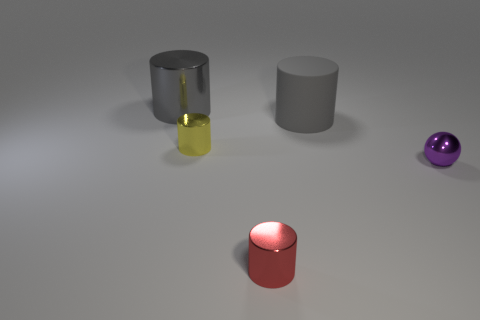Subtract all red cylinders. How many cylinders are left? 3 Subtract all yellow cylinders. How many cylinders are left? 3 Subtract 1 balls. How many balls are left? 0 Add 3 small purple shiny blocks. How many objects exist? 8 Subtract all cylinders. How many objects are left? 1 Subtract all green balls. How many blue cylinders are left? 0 Subtract all big blue objects. Subtract all gray cylinders. How many objects are left? 3 Add 4 yellow objects. How many yellow objects are left? 5 Add 5 red cylinders. How many red cylinders exist? 6 Subtract 1 purple spheres. How many objects are left? 4 